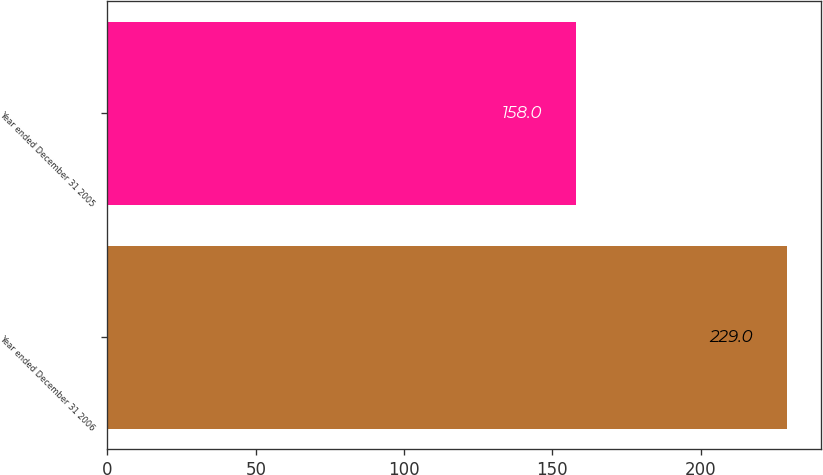Convert chart to OTSL. <chart><loc_0><loc_0><loc_500><loc_500><bar_chart><fcel>Year ended December 31 2006<fcel>Year ended December 31 2005<nl><fcel>229<fcel>158<nl></chart> 